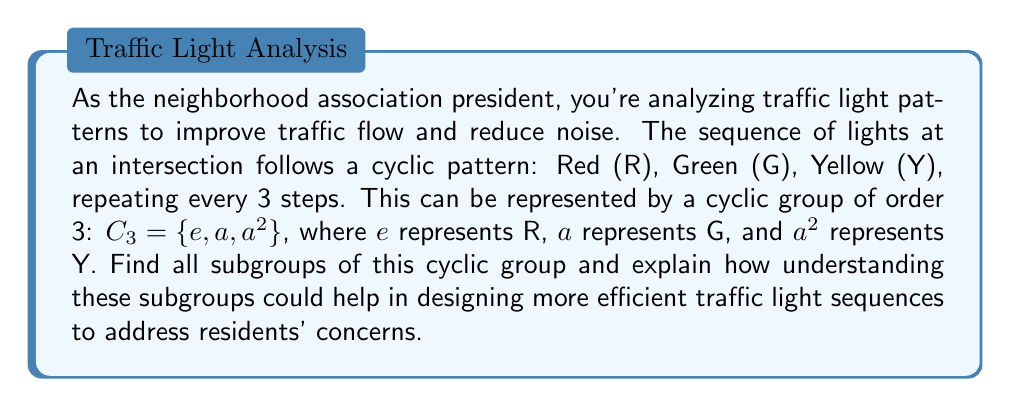What is the answer to this math problem? To find the subgroups of the cyclic group $C_3$, we need to consider the following steps:

1) First, recall that every group has two trivial subgroups: the group itself and the subgroup containing only the identity element.

   - $\{e, a, a^2\}$ (the entire group $C_3$)
   - $\{e\}$ (the identity subgroup)

2) For cyclic groups, the order of any subgroup must divide the order of the group. The order of $C_3$ is 3, which is prime. The only positive divisors of 3 are 1 and 3.

3) We've already found subgroups of order 1 (the identity subgroup) and 3 (the entire group). There are no subgroups of order 2 because 2 doesn't divide 3.

4) Therefore, $C_3$ has no non-trivial proper subgroups.

Understanding these subgroups can help in designing traffic light sequences:

- The trivial subgroup $\{e\}$ represents a constant red light, which could be used in emergency situations or late at night to reduce unnecessary stops and noise.

- The full group $C_3 = \{e, a, a^2\}$ represents the standard cycling of lights, which is necessary during regular traffic hours.

- The lack of other subgroups indicates that this simple 3-state system doesn't have intermediate options. To address residents' concerns, you might consider proposing a more complex system (e.g., a larger cyclic group) that allows for more flexible light sequences, potentially reducing wait times and traffic noise.
Answer: The subgroups of $C_3$ are:
1) $\{e, a, a^2\}$ (the entire group)
2) $\{e\}$ (the identity subgroup) 